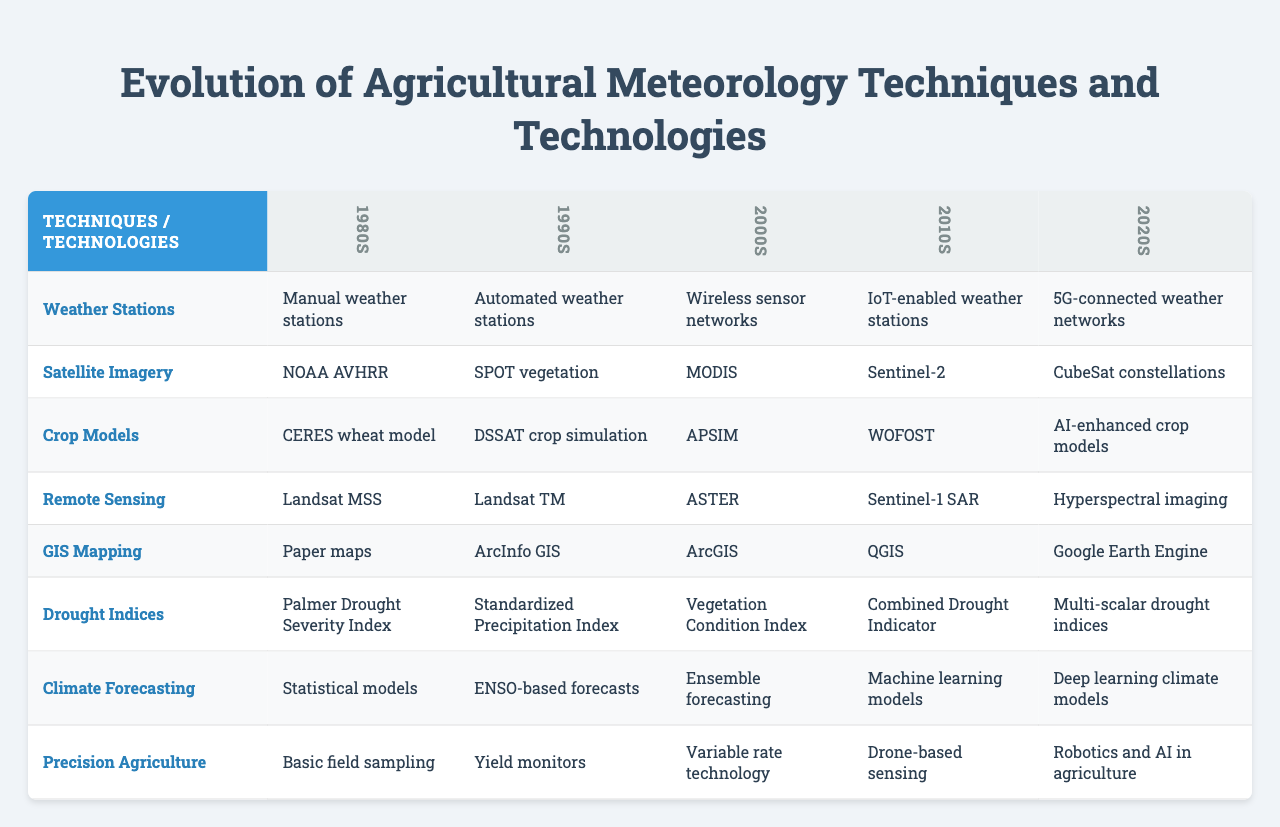What agricultural meteorology technology was first used in the 1980s? The table shows that "Manual weather stations" was the technology listed under the 1980s column for agricultural meteorology techniques.
Answer: Manual weather stations Which decade introduced "Automated weather stations" as a technology? Looking at the table, "Automated weather stations" is found in the 1990s column.
Answer: 1990s What does the 2020s column for Crop Models indicate? The 2020s column lists "AI-enhanced crop models" as the technology used for Crop Models.
Answer: AI-enhanced crop models Did the introduction of weather stations evolve from manual to automated? Yes, the table shows that it started with manual weather stations in the 1980s and evolved to automated weather stations in the 1990s.
Answer: Yes Which technology shows the greatest change in complexity from the 1980s to the 2020s? Comparing the 1980s and 2020s, the progression from "Manual weather stations" to "5G-connected weather networks" reflects a significant increase in complexity.
Answer: Weather stations How many different technologies are listed for Remote Sensing over the decades? Looking at the Remote Sensing row, there are five listed technologies across the decades: Landsat MSS, Landsat TM, ASTER, Sentinel-1 SAR, and Hyperspectral imaging.
Answer: Five For Climate Forecasting, was there a shift from statistical models to machine learning models between the 1990s and 2010s? Yes, the table shows a transition from using "Statistical models" in the 1980s to "Machine learning models" by the 2010s. This indicates a shift in methodology.
Answer: Yes What is the difference in the agricultural technology used for GIS Mapping between the 1990s and the 2020s? The 1990s utilized "ArcInfo GIS," while the 2020s moved to "Google Earth Engine," indicating an upgrade in technology from a software-based system to a more advanced cloud-based system.
Answer: ArcInfo GIS and Google Earth Engine In terms of technological advancement, which decade saw the introduction of Robotics in agriculture? The table shows that "Robotics and AI in agriculture" was introduced during the 2020s, indicating that it is a relatively recent advancement in the field.
Answer: 2020s Which decade marks the introduction of "Precision Agriculture" techniques? The table indicates that the concept of "Precision Agriculture" originated in the 2000s, as evidenced by the technologies listed in that decade.
Answer: 2000s 